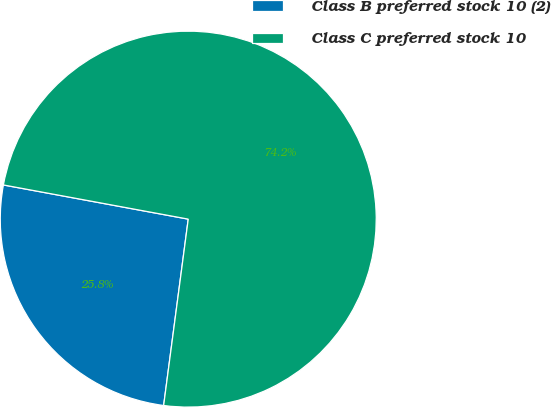Convert chart. <chart><loc_0><loc_0><loc_500><loc_500><pie_chart><fcel>Class B preferred stock 10 (2)<fcel>Class C preferred stock 10<nl><fcel>25.82%<fcel>74.18%<nl></chart> 